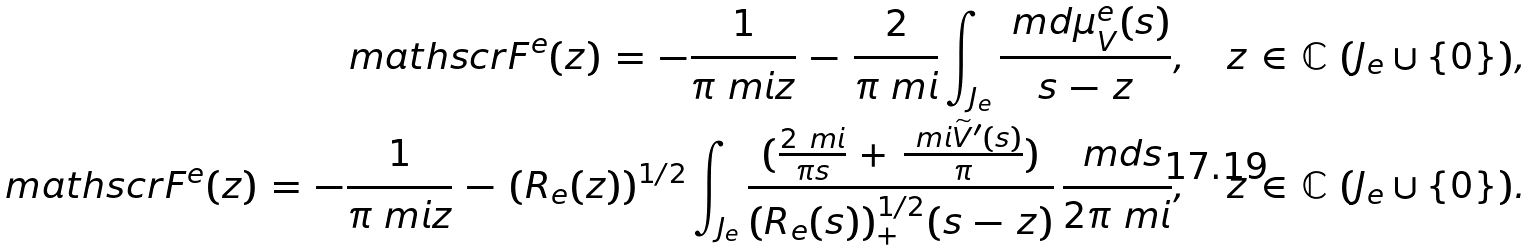<formula> <loc_0><loc_0><loc_500><loc_500>\ m a t h s c r { F } ^ { e } ( z ) \, = \, - \frac { 1 } { \pi \ m i z } \, - \, \frac { 2 } { \pi \ m i } \int _ { J _ { e } } \frac { \ m d \mu _ { V } ^ { e } ( s ) } { s \, - \, z } , \quad z \, \in \, \mathbb { C } \ ( J _ { e } \cup \{ 0 \} ) , \\ \ m a t h s c r { F } ^ { e } ( z ) \, = \, - \frac { 1 } { \pi \ m i z } \, - \, ( R _ { e } ( z ) ) ^ { 1 / 2 } \int _ { J _ { e } } \frac { ( \frac { 2 \ m i } { \pi s } \, + \, \frac { \ m i \widetilde { V } ^ { \prime } ( s ) } { \pi } ) } { ( R _ { e } ( s ) ) ^ { 1 / 2 } _ { + } ( s \, - \, z ) } \, \frac { \ m d s } { 2 \pi \ m i } , \quad z \, \in \, \mathbb { C } \ ( J _ { e } \cup \{ 0 \} ) .</formula> 